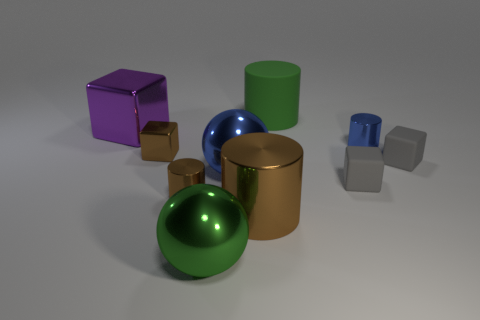Subtract all red cylinders. Subtract all cyan cubes. How many cylinders are left? 4 Subtract all balls. How many objects are left? 8 Add 7 purple matte balls. How many purple matte balls exist? 7 Subtract 2 brown cylinders. How many objects are left? 8 Subtract all cyan shiny cylinders. Subtract all gray things. How many objects are left? 8 Add 4 tiny brown shiny things. How many tiny brown shiny things are left? 6 